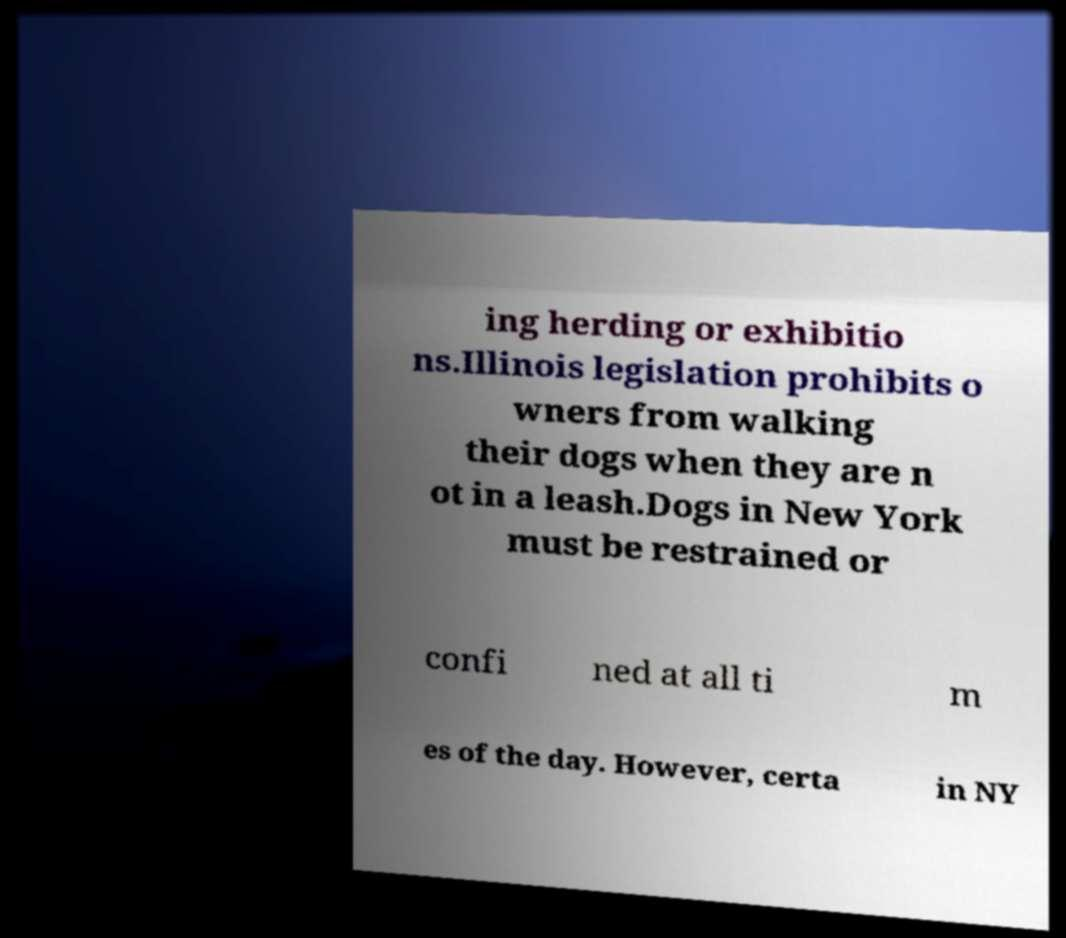Can you read and provide the text displayed in the image?This photo seems to have some interesting text. Can you extract and type it out for me? ing herding or exhibitio ns.Illinois legislation prohibits o wners from walking their dogs when they are n ot in a leash.Dogs in New York must be restrained or confi ned at all ti m es of the day. However, certa in NY 